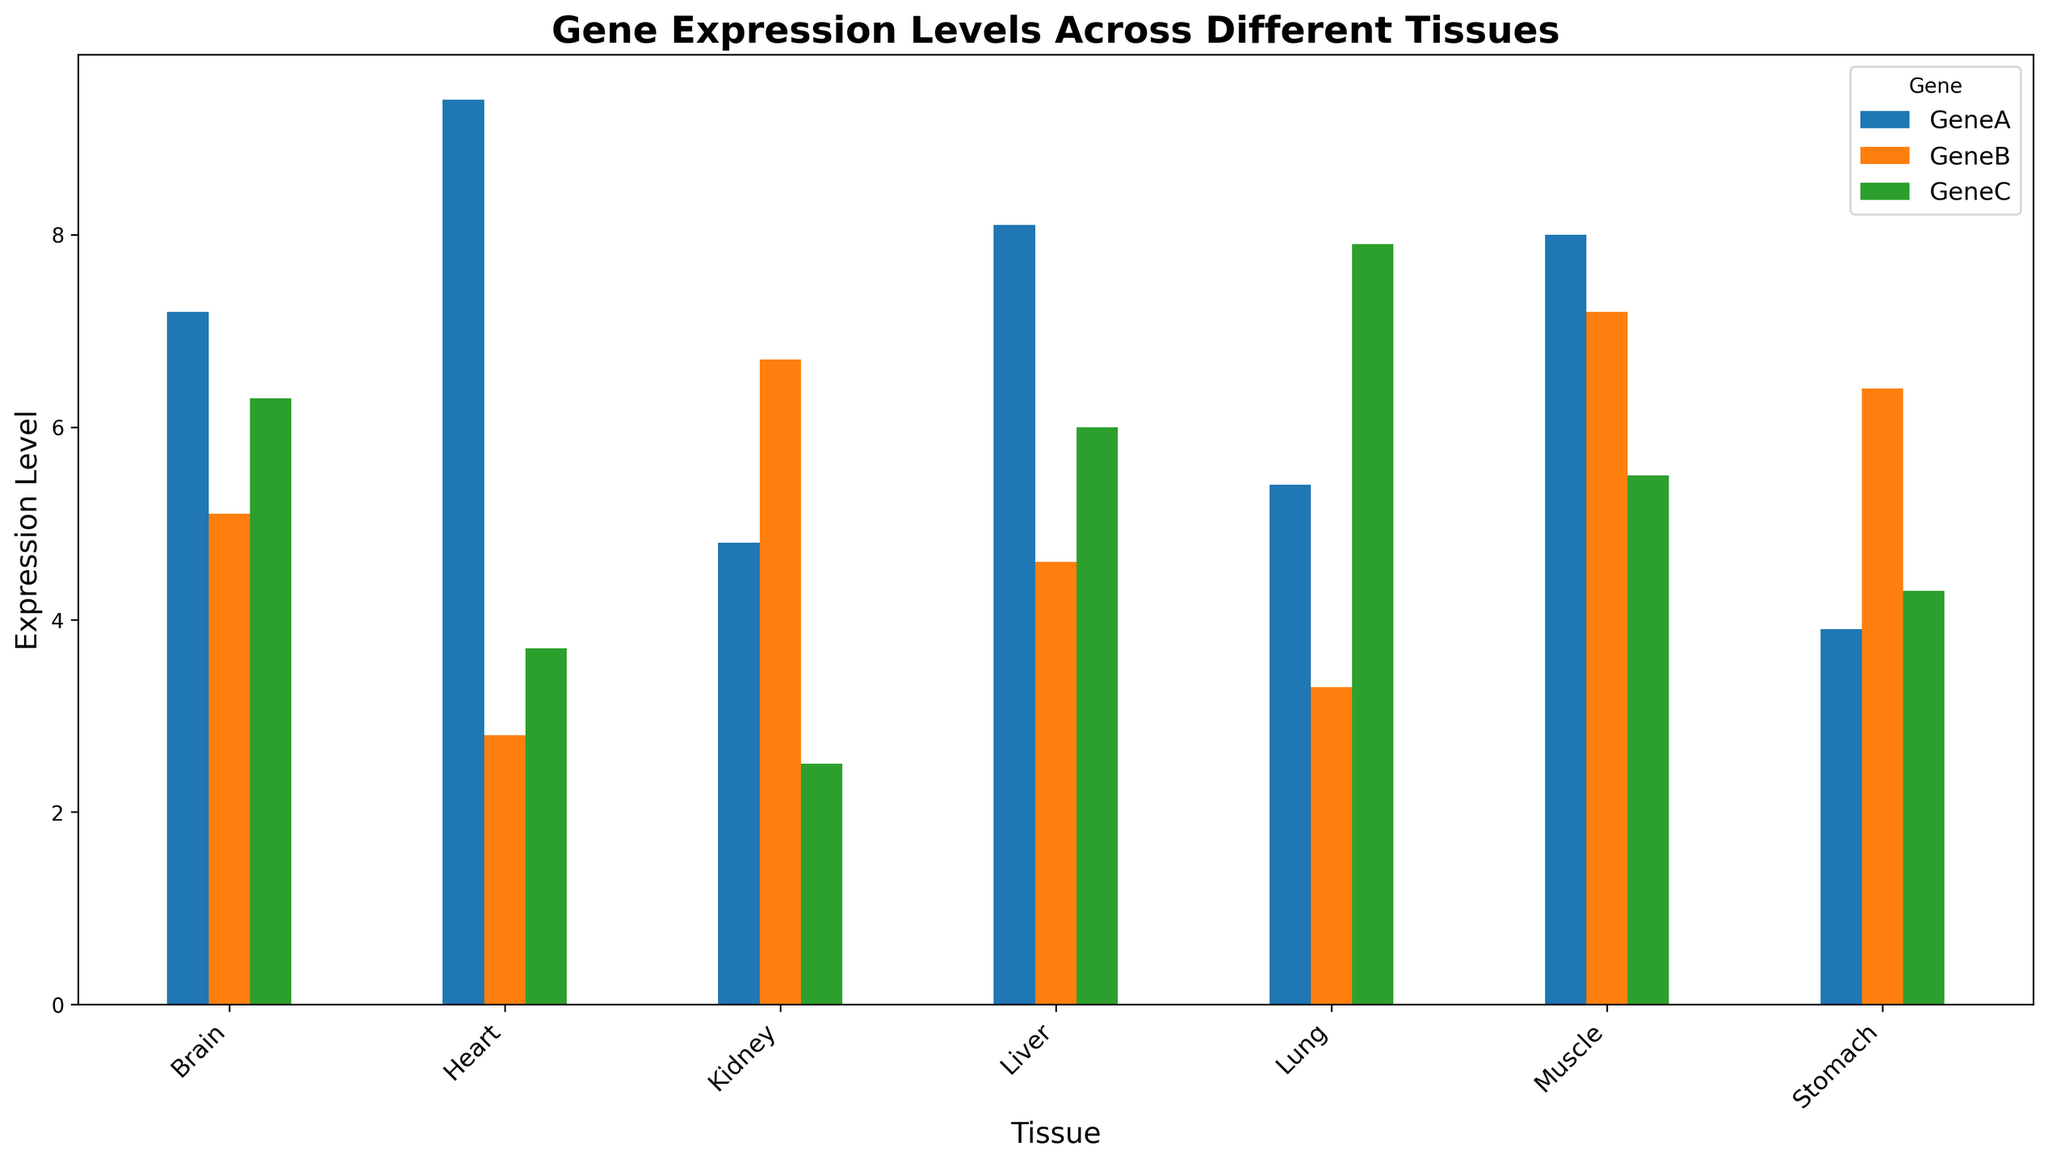Which tissue shows the highest expression level for GeneC? To find this, look at the height of the bars corresponding to GeneC across all tissues. The highest bar for GeneC is in the Lung tissue.
Answer: Lung Which gene has the lowest expression level in the Heart tissue? Check the height of each bar for the Heart tissue. The lowest bar for Heart is for GeneB with an expression level of 2.8.
Answer: GeneB What is the average expression level of GeneA across all tissues? Add up the expression levels for GeneA in all tissues and divide by the number of tissues: (7.2 + 9.4 + 8.1 + 5.4 + 4.8 + 8.0 + 3.9) / 7.
Answer: 6.97 Which tissue shows the greatest variation in expression levels between the genes? Look for the tissue with the widest range between the highest and lowest bars. The Heart tissue has the largest variation (9.4 for GeneA and 2.8 for GeneB).
Answer: Heart Compare the expression levels of GeneB and GeneC in the Muscle tissue. Which is greater? In the Muscle tissue, observe the heights of the bars for GeneB and GeneC. GeneB has a higher expression level (7.2) compared to GeneC (5.5).
Answer: GeneB In which tissue are GeneA and GeneB closest in expression levels? Identify the tissues where the heights of the bars for GeneA and GeneB are most similar. In the Brain tissue, GeneA and GeneB have the closest expression levels, with 7.2 and 5.1, respectively, a difference of 2.1.
Answer: Brain What is the difference in GeneC expression levels between Lung and Kidney tissues? Subtract the expression level of GeneC in Kidney from that in Lung: 7.9 (Lung) - 2.5 (Kidney).
Answer: 5.4 Which tissue has the highest overall average expression level across all genes? Calculate the average expression level for each tissue by summing the expression levels of all genes and dividing by 3. The Heart tissue has the highest average: (9.4 + 2.8 + 3.7) / 3 = 5.3.
Answer: Heart What is the total expression level of GeneB across all tissues? Sum the expression levels of GeneB in all tissues: 5.1 + 2.8 + 4.6 + 3.3 + 6.7 + 7.2 + 6.4.
Answer: 36.1 